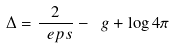<formula> <loc_0><loc_0><loc_500><loc_500>\Delta = \frac { 2 } { \ e p s } - \ g + \log 4 \pi</formula> 